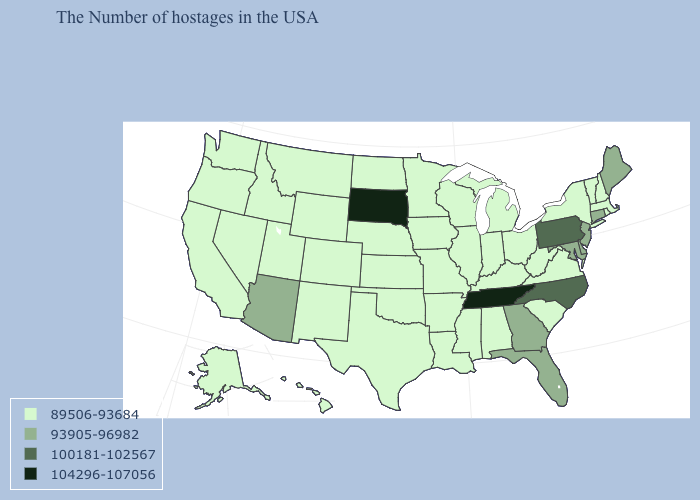What is the value of Massachusetts?
Short answer required. 89506-93684. Does North Dakota have the lowest value in the MidWest?
Answer briefly. Yes. Which states have the lowest value in the MidWest?
Quick response, please. Ohio, Michigan, Indiana, Wisconsin, Illinois, Missouri, Minnesota, Iowa, Kansas, Nebraska, North Dakota. What is the value of Indiana?
Keep it brief. 89506-93684. Among the states that border South Dakota , which have the highest value?
Give a very brief answer. Minnesota, Iowa, Nebraska, North Dakota, Wyoming, Montana. Which states have the highest value in the USA?
Write a very short answer. Tennessee, South Dakota. Which states have the lowest value in the USA?
Short answer required. Massachusetts, Rhode Island, New Hampshire, Vermont, New York, Virginia, South Carolina, West Virginia, Ohio, Michigan, Kentucky, Indiana, Alabama, Wisconsin, Illinois, Mississippi, Louisiana, Missouri, Arkansas, Minnesota, Iowa, Kansas, Nebraska, Oklahoma, Texas, North Dakota, Wyoming, Colorado, New Mexico, Utah, Montana, Idaho, Nevada, California, Washington, Oregon, Alaska, Hawaii. What is the lowest value in the South?
Give a very brief answer. 89506-93684. What is the lowest value in the USA?
Give a very brief answer. 89506-93684. What is the value of Wyoming?
Keep it brief. 89506-93684. Does Florida have a lower value than South Carolina?
Keep it brief. No. What is the highest value in the MidWest ?
Quick response, please. 104296-107056. Name the states that have a value in the range 93905-96982?
Quick response, please. Maine, Connecticut, New Jersey, Delaware, Maryland, Florida, Georgia, Arizona. Which states have the highest value in the USA?
Concise answer only. Tennessee, South Dakota. 